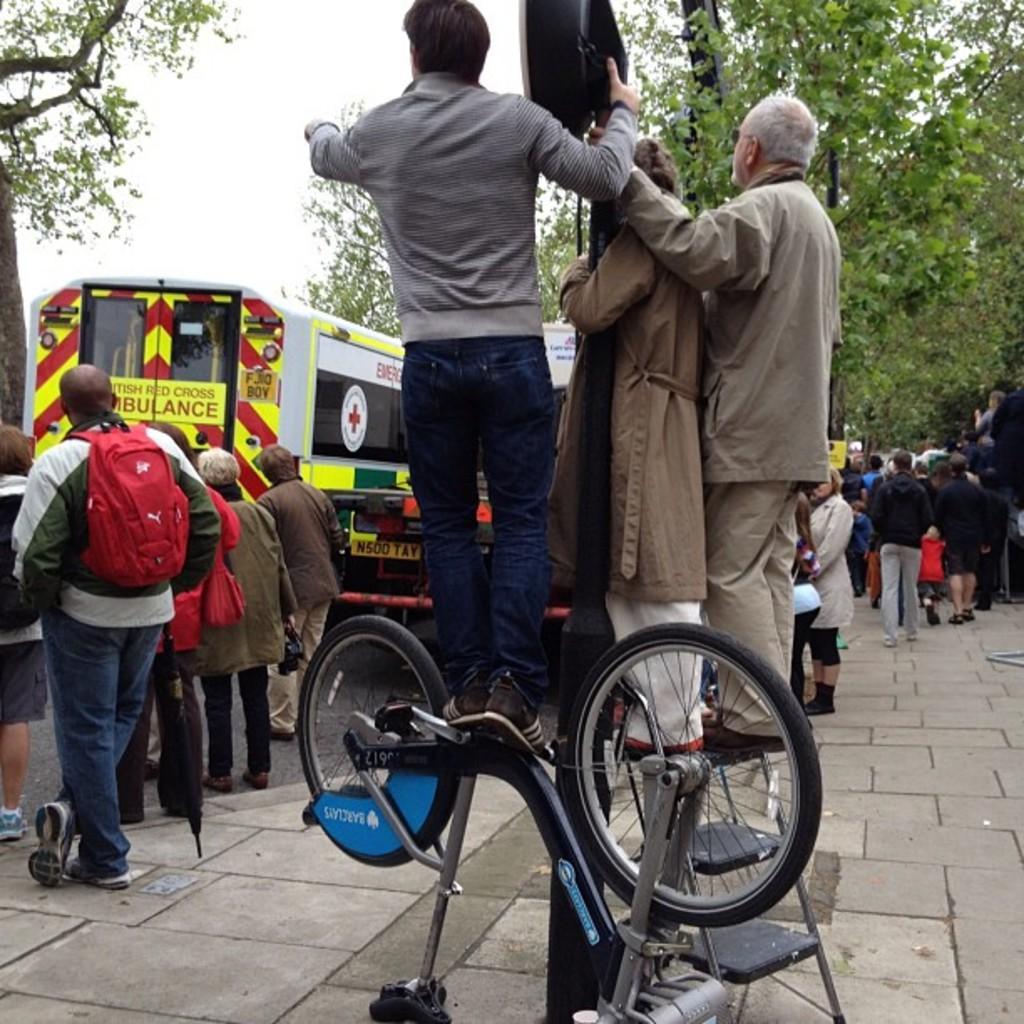Can you describe this image briefly? In this image there is a group people few are standing and few are walking. In front people are standing on the ladder. At the top there is a sky, at the back there is a tree. 